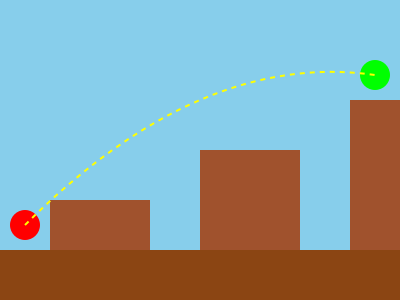In this side-scrolling platformer level design, what hidden shortcut could a speedrunner potentially utilize to reach the end goal more quickly? 1. Analyze the level layout:
   - The player starts at the bottom left (red circle)
   - The goal is at the top right (green circle)
   - There are three platforms of varying heights

2. Consider standard route:
   - Players would typically jump from platform to platform
   - This route would take longer and require multiple jumps

3. Identify potential shortcut:
   - A curved, dashed yellow line connects the start to the goal
   - This line suggests a possible alternate path

4. Evaluate shortcut feasibility:
   - The curve of the line implies a long jump or special move
   - It bypasses all platforms, saving significant time

5. Apply speedrunning knowledge:
   - Many platformers have techniques like long jumps or wall jumps
   - Some games have hidden mechanics or glitches for crossing large gaps

6. Conclude:
   - The optimal shortcut would be a single, long jump or special move from the starting point directly to the goal
   - This would skip all intermediate platforms and minimize time
Answer: Long jump/special move from start to goal 